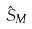<formula> <loc_0><loc_0><loc_500><loc_500>\hat { S } _ { M }</formula> 